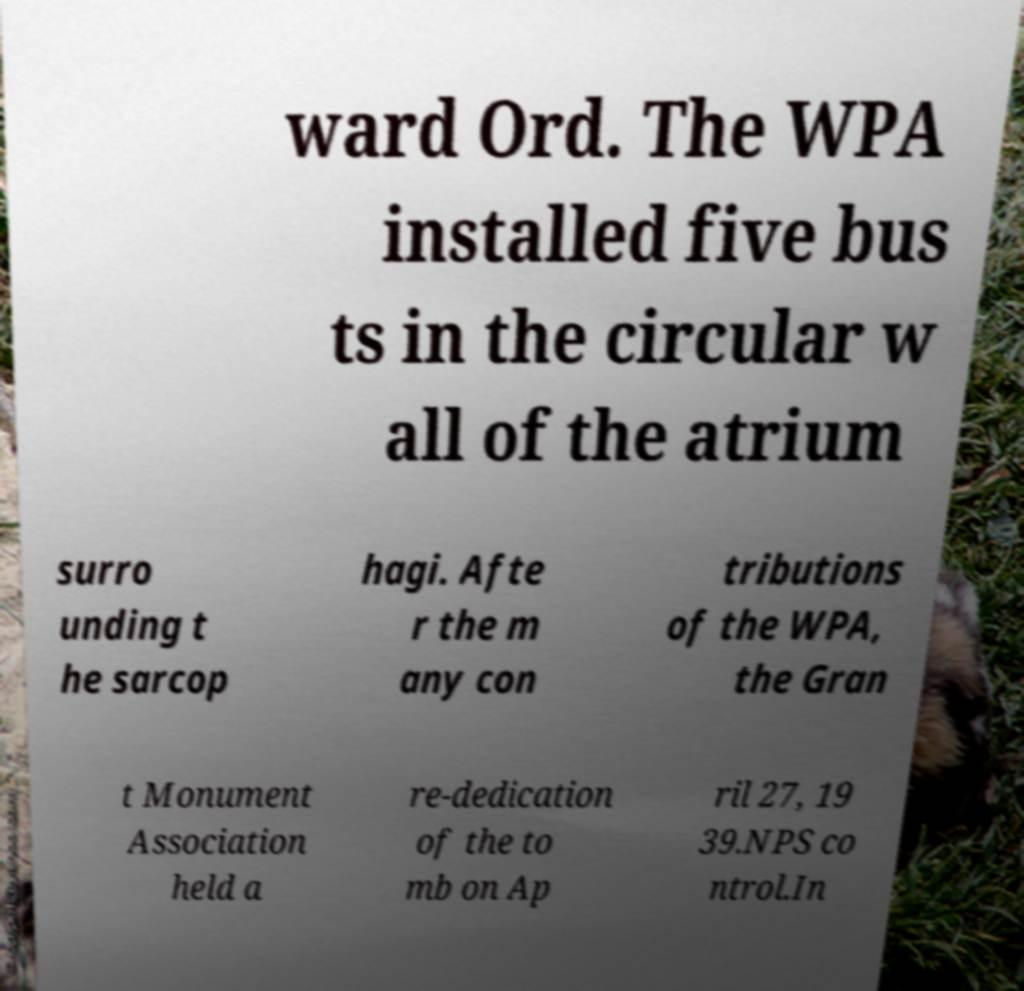I need the written content from this picture converted into text. Can you do that? ward Ord. The WPA installed five bus ts in the circular w all of the atrium surro unding t he sarcop hagi. Afte r the m any con tributions of the WPA, the Gran t Monument Association held a re-dedication of the to mb on Ap ril 27, 19 39.NPS co ntrol.In 